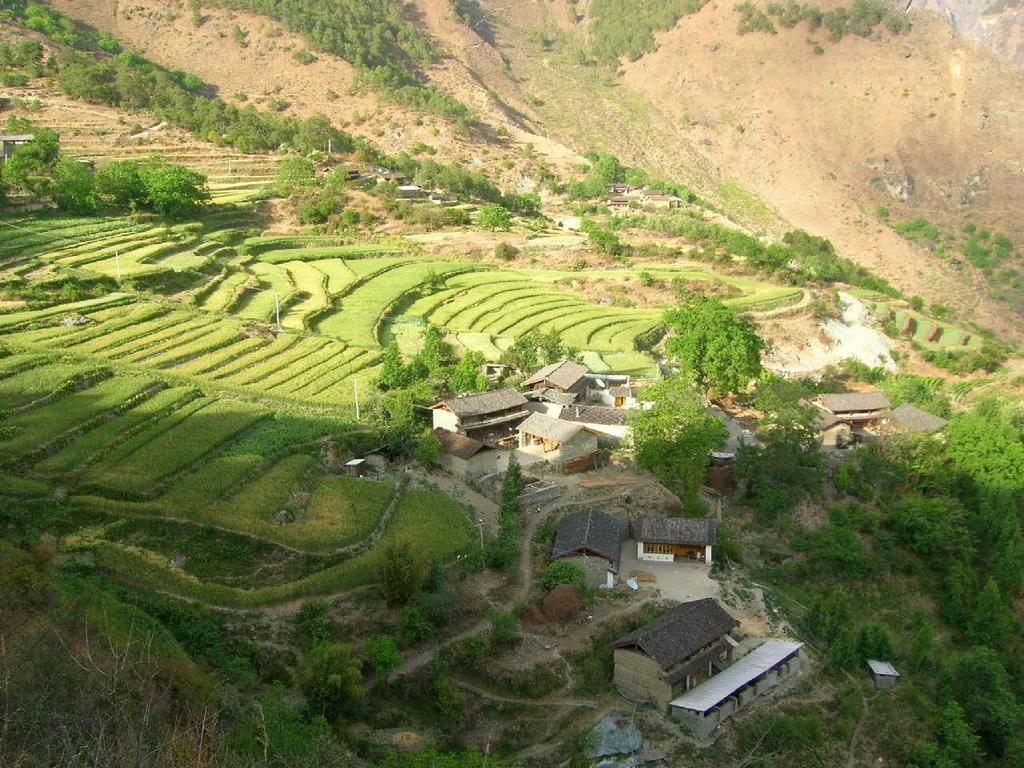What type of structures can be seen in the image? There are houses in the image. What type of natural elements are present in the image? There are trees and mountains in the image. What type of land use can be observed in the image? There are farms in the image. Can you describe the location of the image based on the visible features? The image may have been taken near the mountains. How many spiders can be seen climbing on the houses in the image? There are no spiders visible in the image. What type of clothing accessory is present on the trees in the image? There are no clothing accessories present on the trees in the image. 